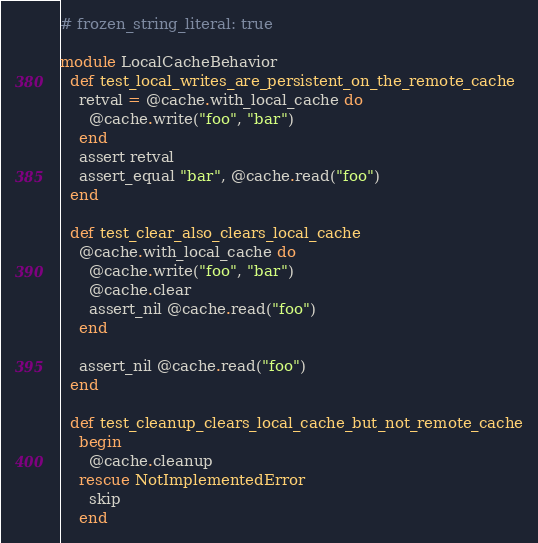<code> <loc_0><loc_0><loc_500><loc_500><_Ruby_># frozen_string_literal: true

module LocalCacheBehavior
  def test_local_writes_are_persistent_on_the_remote_cache
    retval = @cache.with_local_cache do
      @cache.write("foo", "bar")
    end
    assert retval
    assert_equal "bar", @cache.read("foo")
  end

  def test_clear_also_clears_local_cache
    @cache.with_local_cache do
      @cache.write("foo", "bar")
      @cache.clear
      assert_nil @cache.read("foo")
    end

    assert_nil @cache.read("foo")
  end

  def test_cleanup_clears_local_cache_but_not_remote_cache
    begin
      @cache.cleanup
    rescue NotImplementedError
      skip
    end
</code> 